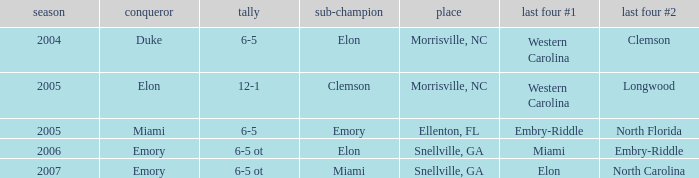Which team was the second semi finalist in 2007? North Carolina. 